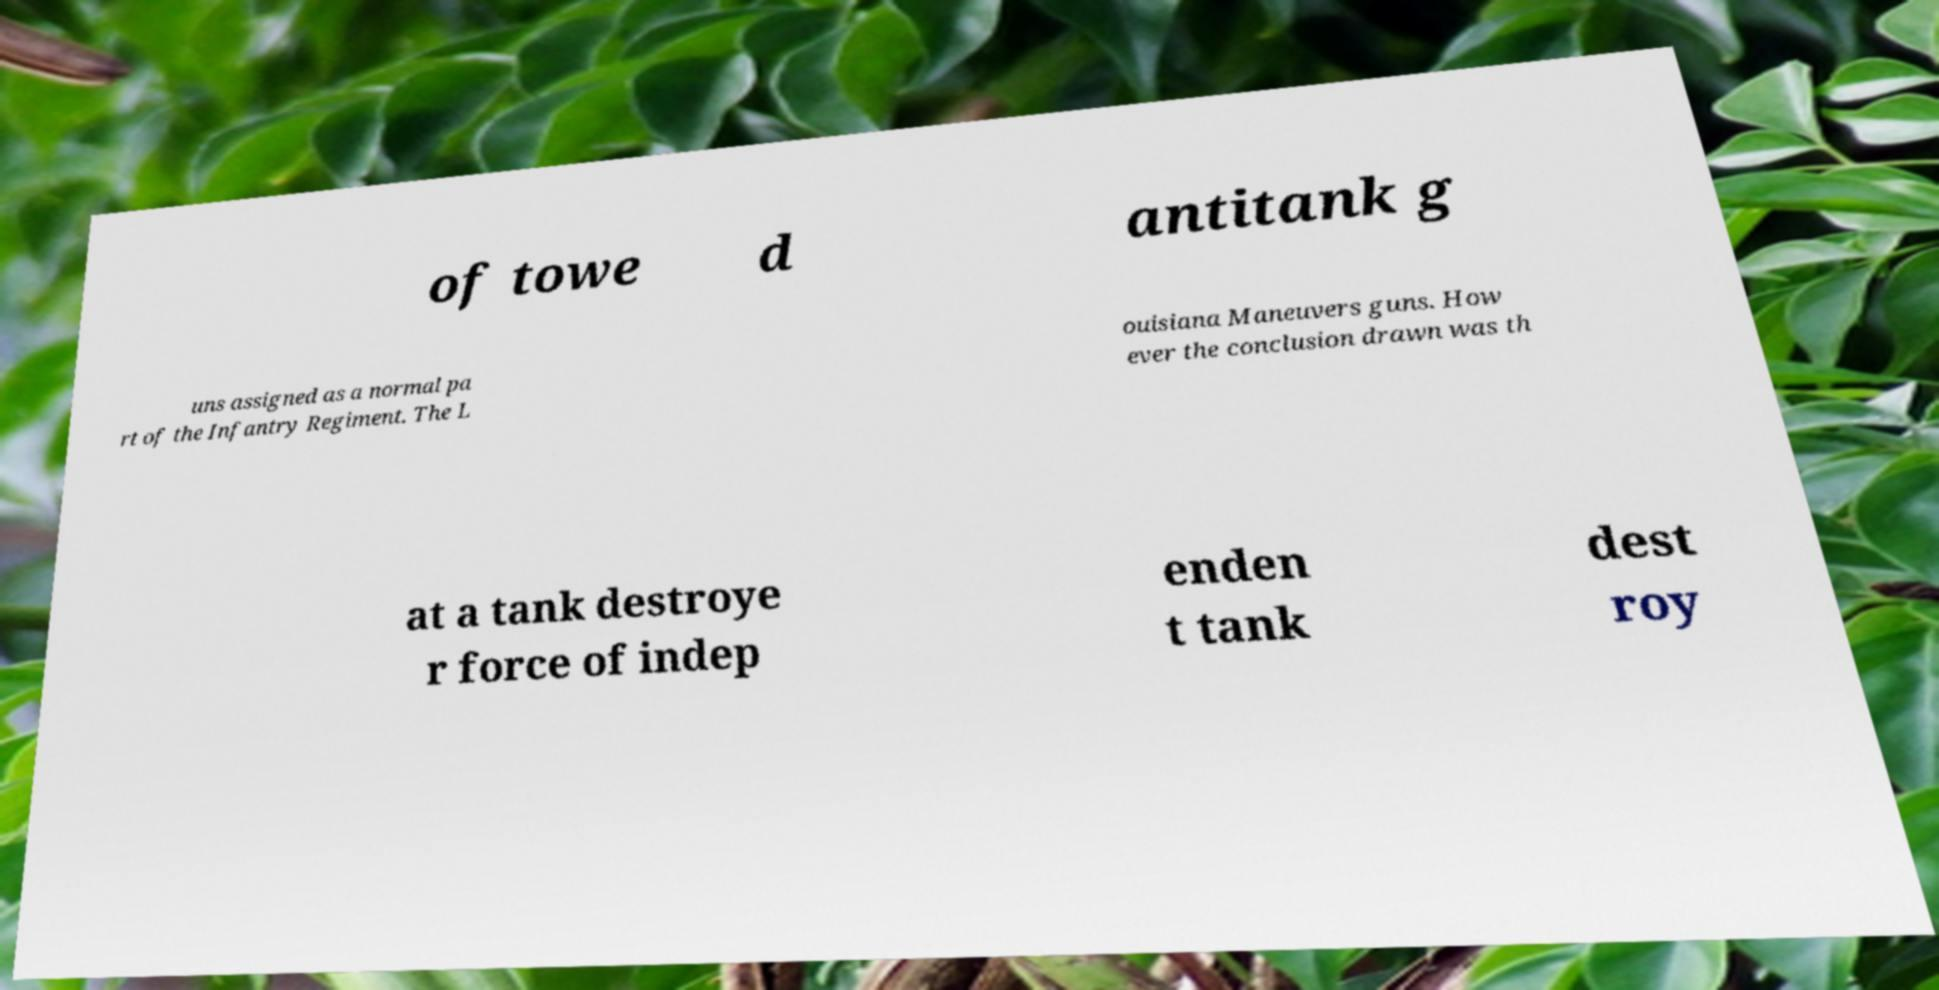For documentation purposes, I need the text within this image transcribed. Could you provide that? of towe d antitank g uns assigned as a normal pa rt of the Infantry Regiment. The L ouisiana Maneuvers guns. How ever the conclusion drawn was th at a tank destroye r force of indep enden t tank dest roy 